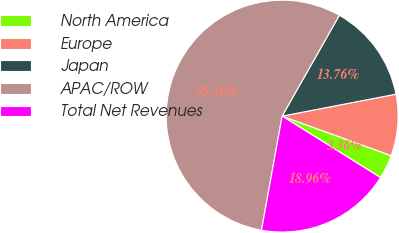<chart> <loc_0><loc_0><loc_500><loc_500><pie_chart><fcel>North America<fcel>Europe<fcel>Japan<fcel>APAC/ROW<fcel>Total Net Revenues<nl><fcel>3.36%<fcel>8.56%<fcel>13.76%<fcel>55.37%<fcel>18.96%<nl></chart> 